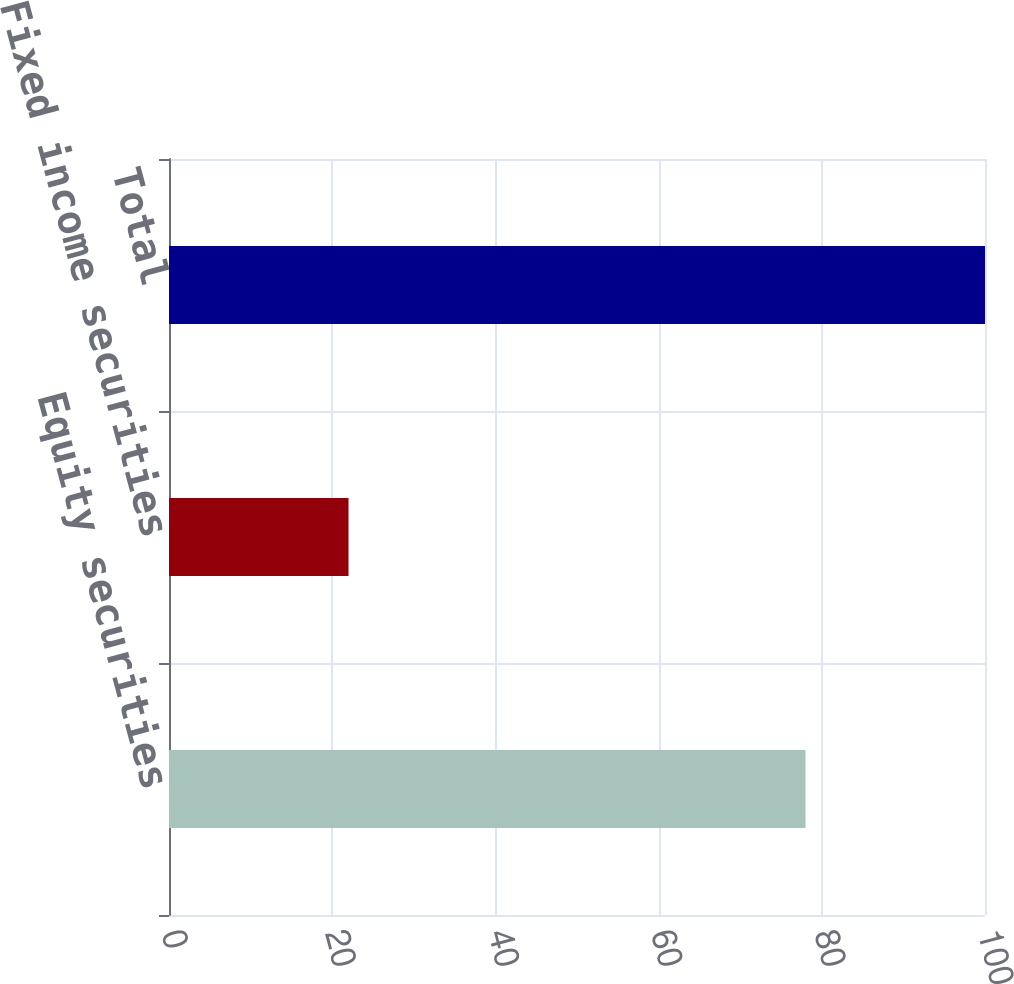Convert chart to OTSL. <chart><loc_0><loc_0><loc_500><loc_500><bar_chart><fcel>Equity securities<fcel>Fixed income securities<fcel>Total<nl><fcel>78<fcel>22<fcel>100<nl></chart> 